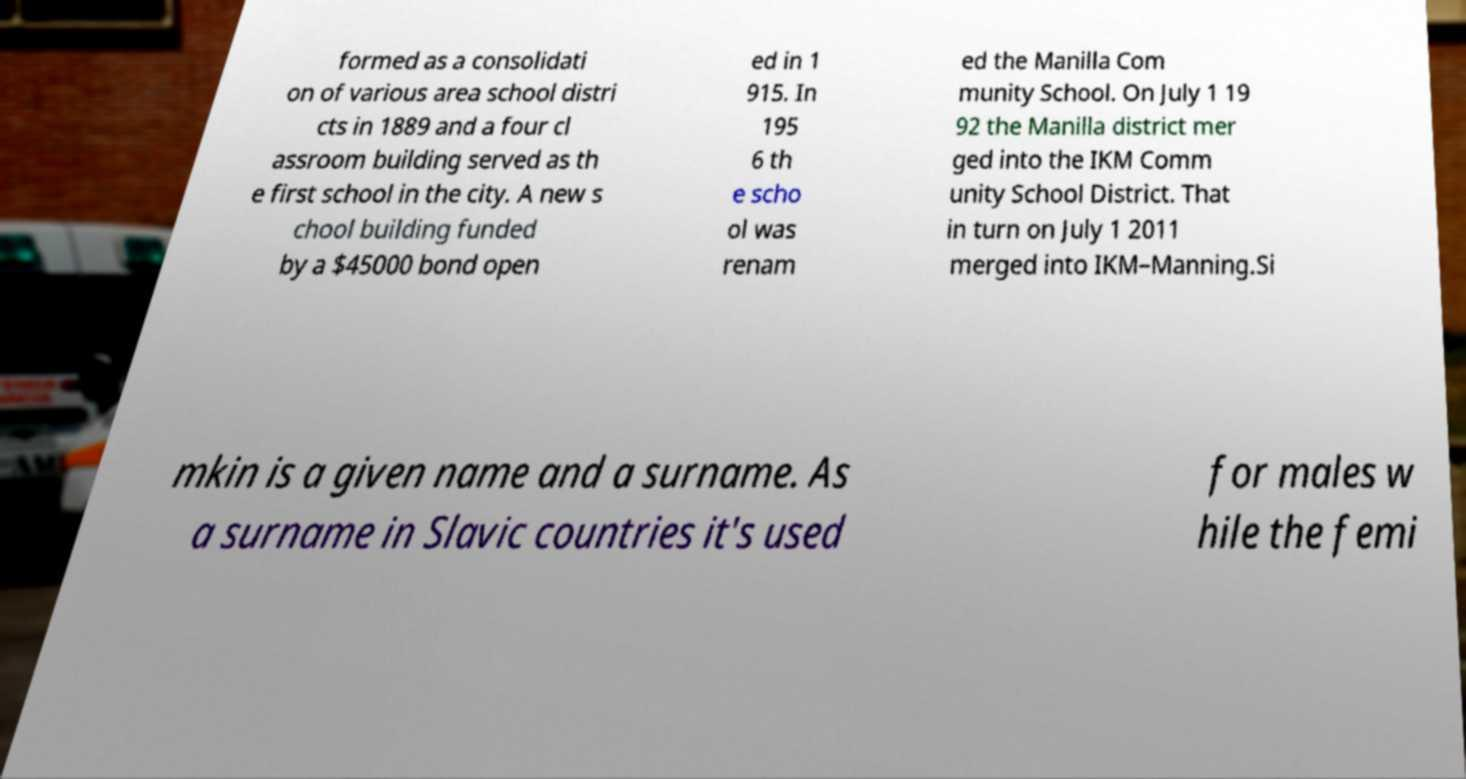For documentation purposes, I need the text within this image transcribed. Could you provide that? formed as a consolidati on of various area school distri cts in 1889 and a four cl assroom building served as th e first school in the city. A new s chool building funded by a $45000 bond open ed in 1 915. In 195 6 th e scho ol was renam ed the Manilla Com munity School. On July 1 19 92 the Manilla district mer ged into the IKM Comm unity School District. That in turn on July 1 2011 merged into IKM–Manning.Si mkin is a given name and a surname. As a surname in Slavic countries it's used for males w hile the femi 